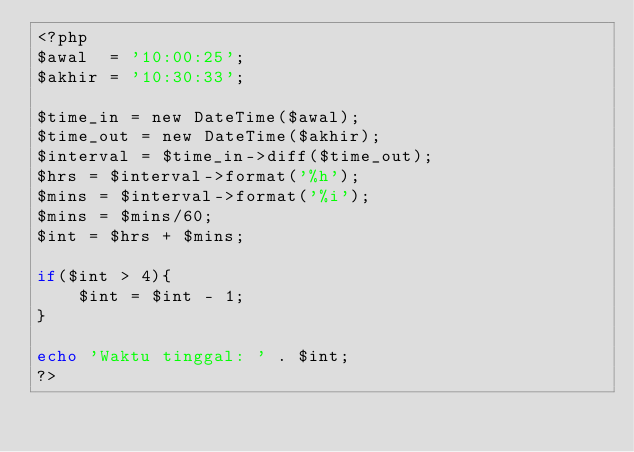Convert code to text. <code><loc_0><loc_0><loc_500><loc_500><_PHP_><?php 
$awal  = '10:00:25';
$akhir = '10:30:33';

$time_in = new DateTime($awal);
$time_out = new DateTime($akhir);
$interval = $time_in->diff($time_out);
$hrs = $interval->format('%h');
$mins = $interval->format('%i');
$mins = $mins/60;
$int = $hrs + $mins;

if($int > 4){
	$int = $int - 1;
}

echo 'Waktu tinggal: ' . $int;
?></code> 